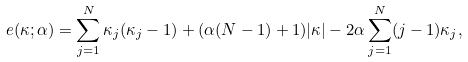Convert formula to latex. <formula><loc_0><loc_0><loc_500><loc_500>e ( \kappa ; \alpha ) = \sum _ { j = 1 } ^ { N } \kappa _ { j } ( \kappa _ { j } - 1 ) + ( \alpha ( N - 1 ) + 1 ) | \kappa | - 2 \alpha \sum _ { j = 1 } ^ { N } ( j - 1 ) \kappa _ { j } ,</formula> 